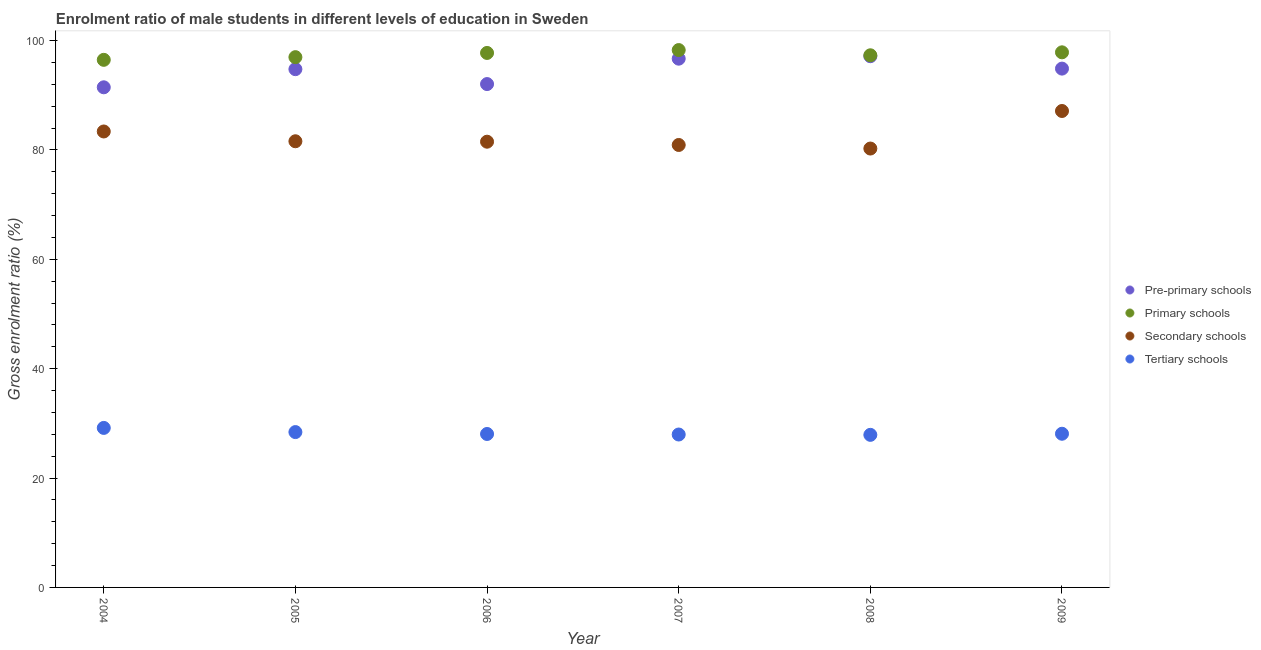How many different coloured dotlines are there?
Offer a very short reply. 4. Is the number of dotlines equal to the number of legend labels?
Offer a terse response. Yes. What is the gross enrolment ratio(female) in primary schools in 2007?
Ensure brevity in your answer.  98.28. Across all years, what is the maximum gross enrolment ratio(female) in secondary schools?
Ensure brevity in your answer.  87.13. Across all years, what is the minimum gross enrolment ratio(female) in secondary schools?
Your answer should be very brief. 80.27. In which year was the gross enrolment ratio(female) in tertiary schools maximum?
Provide a short and direct response. 2004. In which year was the gross enrolment ratio(female) in pre-primary schools minimum?
Provide a succinct answer. 2004. What is the total gross enrolment ratio(female) in pre-primary schools in the graph?
Provide a succinct answer. 567.05. What is the difference between the gross enrolment ratio(female) in primary schools in 2007 and that in 2009?
Ensure brevity in your answer.  0.41. What is the difference between the gross enrolment ratio(female) in primary schools in 2004 and the gross enrolment ratio(female) in tertiary schools in 2005?
Your response must be concise. 68.08. What is the average gross enrolment ratio(female) in pre-primary schools per year?
Your answer should be very brief. 94.51. In the year 2004, what is the difference between the gross enrolment ratio(female) in tertiary schools and gross enrolment ratio(female) in secondary schools?
Give a very brief answer. -54.21. What is the ratio of the gross enrolment ratio(female) in pre-primary schools in 2004 to that in 2005?
Make the answer very short. 0.97. Is the difference between the gross enrolment ratio(female) in secondary schools in 2004 and 2008 greater than the difference between the gross enrolment ratio(female) in primary schools in 2004 and 2008?
Provide a short and direct response. Yes. What is the difference between the highest and the second highest gross enrolment ratio(female) in secondary schools?
Offer a terse response. 3.75. What is the difference between the highest and the lowest gross enrolment ratio(female) in tertiary schools?
Your response must be concise. 1.27. In how many years, is the gross enrolment ratio(female) in secondary schools greater than the average gross enrolment ratio(female) in secondary schools taken over all years?
Your answer should be compact. 2. Is the sum of the gross enrolment ratio(female) in primary schools in 2006 and 2009 greater than the maximum gross enrolment ratio(female) in pre-primary schools across all years?
Offer a very short reply. Yes. Is it the case that in every year, the sum of the gross enrolment ratio(female) in pre-primary schools and gross enrolment ratio(female) in primary schools is greater than the gross enrolment ratio(female) in secondary schools?
Offer a terse response. Yes. Is the gross enrolment ratio(female) in tertiary schools strictly greater than the gross enrolment ratio(female) in pre-primary schools over the years?
Offer a terse response. No. Is the gross enrolment ratio(female) in secondary schools strictly less than the gross enrolment ratio(female) in tertiary schools over the years?
Ensure brevity in your answer.  No. How many dotlines are there?
Ensure brevity in your answer.  4. What is the difference between two consecutive major ticks on the Y-axis?
Provide a short and direct response. 20. Are the values on the major ticks of Y-axis written in scientific E-notation?
Ensure brevity in your answer.  No. Does the graph contain any zero values?
Offer a very short reply. No. Does the graph contain grids?
Make the answer very short. No. How many legend labels are there?
Give a very brief answer. 4. How are the legend labels stacked?
Provide a succinct answer. Vertical. What is the title of the graph?
Ensure brevity in your answer.  Enrolment ratio of male students in different levels of education in Sweden. What is the Gross enrolment ratio (%) in Pre-primary schools in 2004?
Offer a terse response. 91.47. What is the Gross enrolment ratio (%) in Primary schools in 2004?
Offer a terse response. 96.49. What is the Gross enrolment ratio (%) of Secondary schools in 2004?
Offer a very short reply. 83.39. What is the Gross enrolment ratio (%) in Tertiary schools in 2004?
Your answer should be compact. 29.17. What is the Gross enrolment ratio (%) of Pre-primary schools in 2005?
Keep it short and to the point. 94.78. What is the Gross enrolment ratio (%) of Primary schools in 2005?
Give a very brief answer. 96.98. What is the Gross enrolment ratio (%) in Secondary schools in 2005?
Your answer should be compact. 81.6. What is the Gross enrolment ratio (%) in Tertiary schools in 2005?
Offer a terse response. 28.41. What is the Gross enrolment ratio (%) of Pre-primary schools in 2006?
Provide a succinct answer. 92.06. What is the Gross enrolment ratio (%) in Primary schools in 2006?
Ensure brevity in your answer.  97.75. What is the Gross enrolment ratio (%) in Secondary schools in 2006?
Keep it short and to the point. 81.52. What is the Gross enrolment ratio (%) in Tertiary schools in 2006?
Ensure brevity in your answer.  28.06. What is the Gross enrolment ratio (%) in Pre-primary schools in 2007?
Your answer should be very brief. 96.7. What is the Gross enrolment ratio (%) of Primary schools in 2007?
Give a very brief answer. 98.28. What is the Gross enrolment ratio (%) in Secondary schools in 2007?
Make the answer very short. 80.92. What is the Gross enrolment ratio (%) of Tertiary schools in 2007?
Offer a very short reply. 27.97. What is the Gross enrolment ratio (%) of Pre-primary schools in 2008?
Your answer should be compact. 97.15. What is the Gross enrolment ratio (%) in Primary schools in 2008?
Your answer should be compact. 97.32. What is the Gross enrolment ratio (%) in Secondary schools in 2008?
Provide a short and direct response. 80.27. What is the Gross enrolment ratio (%) in Tertiary schools in 2008?
Provide a succinct answer. 27.9. What is the Gross enrolment ratio (%) of Pre-primary schools in 2009?
Give a very brief answer. 94.89. What is the Gross enrolment ratio (%) of Primary schools in 2009?
Keep it short and to the point. 97.86. What is the Gross enrolment ratio (%) of Secondary schools in 2009?
Keep it short and to the point. 87.13. What is the Gross enrolment ratio (%) of Tertiary schools in 2009?
Your response must be concise. 28.11. Across all years, what is the maximum Gross enrolment ratio (%) in Pre-primary schools?
Your response must be concise. 97.15. Across all years, what is the maximum Gross enrolment ratio (%) in Primary schools?
Your response must be concise. 98.28. Across all years, what is the maximum Gross enrolment ratio (%) in Secondary schools?
Ensure brevity in your answer.  87.13. Across all years, what is the maximum Gross enrolment ratio (%) of Tertiary schools?
Make the answer very short. 29.17. Across all years, what is the minimum Gross enrolment ratio (%) of Pre-primary schools?
Provide a succinct answer. 91.47. Across all years, what is the minimum Gross enrolment ratio (%) in Primary schools?
Offer a very short reply. 96.49. Across all years, what is the minimum Gross enrolment ratio (%) of Secondary schools?
Make the answer very short. 80.27. Across all years, what is the minimum Gross enrolment ratio (%) of Tertiary schools?
Provide a succinct answer. 27.9. What is the total Gross enrolment ratio (%) in Pre-primary schools in the graph?
Provide a short and direct response. 567.05. What is the total Gross enrolment ratio (%) of Primary schools in the graph?
Ensure brevity in your answer.  584.68. What is the total Gross enrolment ratio (%) in Secondary schools in the graph?
Keep it short and to the point. 494.82. What is the total Gross enrolment ratio (%) of Tertiary schools in the graph?
Provide a succinct answer. 169.62. What is the difference between the Gross enrolment ratio (%) in Pre-primary schools in 2004 and that in 2005?
Your response must be concise. -3.32. What is the difference between the Gross enrolment ratio (%) in Primary schools in 2004 and that in 2005?
Offer a very short reply. -0.49. What is the difference between the Gross enrolment ratio (%) of Secondary schools in 2004 and that in 2005?
Provide a succinct answer. 1.79. What is the difference between the Gross enrolment ratio (%) in Tertiary schools in 2004 and that in 2005?
Offer a very short reply. 0.76. What is the difference between the Gross enrolment ratio (%) in Pre-primary schools in 2004 and that in 2006?
Provide a succinct answer. -0.59. What is the difference between the Gross enrolment ratio (%) of Primary schools in 2004 and that in 2006?
Your answer should be very brief. -1.26. What is the difference between the Gross enrolment ratio (%) of Secondary schools in 2004 and that in 2006?
Offer a terse response. 1.87. What is the difference between the Gross enrolment ratio (%) in Tertiary schools in 2004 and that in 2006?
Provide a succinct answer. 1.11. What is the difference between the Gross enrolment ratio (%) of Pre-primary schools in 2004 and that in 2007?
Your answer should be very brief. -5.23. What is the difference between the Gross enrolment ratio (%) in Primary schools in 2004 and that in 2007?
Make the answer very short. -1.79. What is the difference between the Gross enrolment ratio (%) in Secondary schools in 2004 and that in 2007?
Ensure brevity in your answer.  2.47. What is the difference between the Gross enrolment ratio (%) in Tertiary schools in 2004 and that in 2007?
Offer a very short reply. 1.21. What is the difference between the Gross enrolment ratio (%) of Pre-primary schools in 2004 and that in 2008?
Your answer should be compact. -5.69. What is the difference between the Gross enrolment ratio (%) in Primary schools in 2004 and that in 2008?
Give a very brief answer. -0.83. What is the difference between the Gross enrolment ratio (%) in Secondary schools in 2004 and that in 2008?
Your response must be concise. 3.12. What is the difference between the Gross enrolment ratio (%) in Tertiary schools in 2004 and that in 2008?
Give a very brief answer. 1.27. What is the difference between the Gross enrolment ratio (%) of Pre-primary schools in 2004 and that in 2009?
Give a very brief answer. -3.42. What is the difference between the Gross enrolment ratio (%) of Primary schools in 2004 and that in 2009?
Your answer should be very brief. -1.37. What is the difference between the Gross enrolment ratio (%) of Secondary schools in 2004 and that in 2009?
Provide a short and direct response. -3.75. What is the difference between the Gross enrolment ratio (%) in Tertiary schools in 2004 and that in 2009?
Provide a short and direct response. 1.07. What is the difference between the Gross enrolment ratio (%) in Pre-primary schools in 2005 and that in 2006?
Make the answer very short. 2.72. What is the difference between the Gross enrolment ratio (%) of Primary schools in 2005 and that in 2006?
Keep it short and to the point. -0.77. What is the difference between the Gross enrolment ratio (%) in Secondary schools in 2005 and that in 2006?
Your response must be concise. 0.08. What is the difference between the Gross enrolment ratio (%) in Tertiary schools in 2005 and that in 2006?
Your response must be concise. 0.35. What is the difference between the Gross enrolment ratio (%) of Pre-primary schools in 2005 and that in 2007?
Ensure brevity in your answer.  -1.92. What is the difference between the Gross enrolment ratio (%) of Primary schools in 2005 and that in 2007?
Provide a short and direct response. -1.3. What is the difference between the Gross enrolment ratio (%) in Secondary schools in 2005 and that in 2007?
Give a very brief answer. 0.68. What is the difference between the Gross enrolment ratio (%) of Tertiary schools in 2005 and that in 2007?
Ensure brevity in your answer.  0.44. What is the difference between the Gross enrolment ratio (%) in Pre-primary schools in 2005 and that in 2008?
Give a very brief answer. -2.37. What is the difference between the Gross enrolment ratio (%) of Primary schools in 2005 and that in 2008?
Give a very brief answer. -0.34. What is the difference between the Gross enrolment ratio (%) of Secondary schools in 2005 and that in 2008?
Offer a terse response. 1.33. What is the difference between the Gross enrolment ratio (%) of Tertiary schools in 2005 and that in 2008?
Your answer should be very brief. 0.51. What is the difference between the Gross enrolment ratio (%) of Pre-primary schools in 2005 and that in 2009?
Give a very brief answer. -0.1. What is the difference between the Gross enrolment ratio (%) in Primary schools in 2005 and that in 2009?
Make the answer very short. -0.88. What is the difference between the Gross enrolment ratio (%) of Secondary schools in 2005 and that in 2009?
Provide a succinct answer. -5.54. What is the difference between the Gross enrolment ratio (%) in Tertiary schools in 2005 and that in 2009?
Your answer should be very brief. 0.31. What is the difference between the Gross enrolment ratio (%) in Pre-primary schools in 2006 and that in 2007?
Your response must be concise. -4.64. What is the difference between the Gross enrolment ratio (%) of Primary schools in 2006 and that in 2007?
Keep it short and to the point. -0.53. What is the difference between the Gross enrolment ratio (%) of Secondary schools in 2006 and that in 2007?
Your answer should be very brief. 0.6. What is the difference between the Gross enrolment ratio (%) in Tertiary schools in 2006 and that in 2007?
Your response must be concise. 0.1. What is the difference between the Gross enrolment ratio (%) in Pre-primary schools in 2006 and that in 2008?
Provide a succinct answer. -5.09. What is the difference between the Gross enrolment ratio (%) of Primary schools in 2006 and that in 2008?
Your answer should be compact. 0.43. What is the difference between the Gross enrolment ratio (%) in Secondary schools in 2006 and that in 2008?
Your answer should be very brief. 1.25. What is the difference between the Gross enrolment ratio (%) in Tertiary schools in 2006 and that in 2008?
Keep it short and to the point. 0.16. What is the difference between the Gross enrolment ratio (%) of Pre-primary schools in 2006 and that in 2009?
Your response must be concise. -2.83. What is the difference between the Gross enrolment ratio (%) of Primary schools in 2006 and that in 2009?
Provide a succinct answer. -0.11. What is the difference between the Gross enrolment ratio (%) of Secondary schools in 2006 and that in 2009?
Keep it short and to the point. -5.62. What is the difference between the Gross enrolment ratio (%) of Tertiary schools in 2006 and that in 2009?
Keep it short and to the point. -0.04. What is the difference between the Gross enrolment ratio (%) of Pre-primary schools in 2007 and that in 2008?
Provide a short and direct response. -0.45. What is the difference between the Gross enrolment ratio (%) in Primary schools in 2007 and that in 2008?
Give a very brief answer. 0.95. What is the difference between the Gross enrolment ratio (%) in Secondary schools in 2007 and that in 2008?
Your answer should be compact. 0.65. What is the difference between the Gross enrolment ratio (%) in Tertiary schools in 2007 and that in 2008?
Give a very brief answer. 0.06. What is the difference between the Gross enrolment ratio (%) of Pre-primary schools in 2007 and that in 2009?
Keep it short and to the point. 1.82. What is the difference between the Gross enrolment ratio (%) in Primary schools in 2007 and that in 2009?
Your answer should be very brief. 0.41. What is the difference between the Gross enrolment ratio (%) of Secondary schools in 2007 and that in 2009?
Your answer should be compact. -6.21. What is the difference between the Gross enrolment ratio (%) in Tertiary schools in 2007 and that in 2009?
Your answer should be compact. -0.14. What is the difference between the Gross enrolment ratio (%) in Pre-primary schools in 2008 and that in 2009?
Offer a very short reply. 2.27. What is the difference between the Gross enrolment ratio (%) in Primary schools in 2008 and that in 2009?
Give a very brief answer. -0.54. What is the difference between the Gross enrolment ratio (%) in Secondary schools in 2008 and that in 2009?
Your answer should be very brief. -6.87. What is the difference between the Gross enrolment ratio (%) in Tertiary schools in 2008 and that in 2009?
Keep it short and to the point. -0.2. What is the difference between the Gross enrolment ratio (%) of Pre-primary schools in 2004 and the Gross enrolment ratio (%) of Primary schools in 2005?
Ensure brevity in your answer.  -5.51. What is the difference between the Gross enrolment ratio (%) of Pre-primary schools in 2004 and the Gross enrolment ratio (%) of Secondary schools in 2005?
Give a very brief answer. 9.87. What is the difference between the Gross enrolment ratio (%) of Pre-primary schools in 2004 and the Gross enrolment ratio (%) of Tertiary schools in 2005?
Offer a very short reply. 63.06. What is the difference between the Gross enrolment ratio (%) of Primary schools in 2004 and the Gross enrolment ratio (%) of Secondary schools in 2005?
Your answer should be compact. 14.89. What is the difference between the Gross enrolment ratio (%) of Primary schools in 2004 and the Gross enrolment ratio (%) of Tertiary schools in 2005?
Your answer should be compact. 68.08. What is the difference between the Gross enrolment ratio (%) in Secondary schools in 2004 and the Gross enrolment ratio (%) in Tertiary schools in 2005?
Your answer should be compact. 54.98. What is the difference between the Gross enrolment ratio (%) of Pre-primary schools in 2004 and the Gross enrolment ratio (%) of Primary schools in 2006?
Give a very brief answer. -6.28. What is the difference between the Gross enrolment ratio (%) of Pre-primary schools in 2004 and the Gross enrolment ratio (%) of Secondary schools in 2006?
Offer a very short reply. 9.95. What is the difference between the Gross enrolment ratio (%) in Pre-primary schools in 2004 and the Gross enrolment ratio (%) in Tertiary schools in 2006?
Your answer should be very brief. 63.4. What is the difference between the Gross enrolment ratio (%) in Primary schools in 2004 and the Gross enrolment ratio (%) in Secondary schools in 2006?
Provide a short and direct response. 14.97. What is the difference between the Gross enrolment ratio (%) of Primary schools in 2004 and the Gross enrolment ratio (%) of Tertiary schools in 2006?
Your answer should be compact. 68.43. What is the difference between the Gross enrolment ratio (%) of Secondary schools in 2004 and the Gross enrolment ratio (%) of Tertiary schools in 2006?
Provide a short and direct response. 55.32. What is the difference between the Gross enrolment ratio (%) in Pre-primary schools in 2004 and the Gross enrolment ratio (%) in Primary schools in 2007?
Provide a short and direct response. -6.81. What is the difference between the Gross enrolment ratio (%) in Pre-primary schools in 2004 and the Gross enrolment ratio (%) in Secondary schools in 2007?
Provide a short and direct response. 10.55. What is the difference between the Gross enrolment ratio (%) in Pre-primary schools in 2004 and the Gross enrolment ratio (%) in Tertiary schools in 2007?
Your answer should be very brief. 63.5. What is the difference between the Gross enrolment ratio (%) of Primary schools in 2004 and the Gross enrolment ratio (%) of Secondary schools in 2007?
Offer a very short reply. 15.57. What is the difference between the Gross enrolment ratio (%) of Primary schools in 2004 and the Gross enrolment ratio (%) of Tertiary schools in 2007?
Make the answer very short. 68.52. What is the difference between the Gross enrolment ratio (%) in Secondary schools in 2004 and the Gross enrolment ratio (%) in Tertiary schools in 2007?
Make the answer very short. 55.42. What is the difference between the Gross enrolment ratio (%) of Pre-primary schools in 2004 and the Gross enrolment ratio (%) of Primary schools in 2008?
Your response must be concise. -5.86. What is the difference between the Gross enrolment ratio (%) of Pre-primary schools in 2004 and the Gross enrolment ratio (%) of Secondary schools in 2008?
Provide a short and direct response. 11.2. What is the difference between the Gross enrolment ratio (%) in Pre-primary schools in 2004 and the Gross enrolment ratio (%) in Tertiary schools in 2008?
Keep it short and to the point. 63.56. What is the difference between the Gross enrolment ratio (%) of Primary schools in 2004 and the Gross enrolment ratio (%) of Secondary schools in 2008?
Your response must be concise. 16.22. What is the difference between the Gross enrolment ratio (%) of Primary schools in 2004 and the Gross enrolment ratio (%) of Tertiary schools in 2008?
Make the answer very short. 68.59. What is the difference between the Gross enrolment ratio (%) of Secondary schools in 2004 and the Gross enrolment ratio (%) of Tertiary schools in 2008?
Give a very brief answer. 55.48. What is the difference between the Gross enrolment ratio (%) of Pre-primary schools in 2004 and the Gross enrolment ratio (%) of Primary schools in 2009?
Your answer should be compact. -6.4. What is the difference between the Gross enrolment ratio (%) in Pre-primary schools in 2004 and the Gross enrolment ratio (%) in Secondary schools in 2009?
Make the answer very short. 4.33. What is the difference between the Gross enrolment ratio (%) in Pre-primary schools in 2004 and the Gross enrolment ratio (%) in Tertiary schools in 2009?
Offer a terse response. 63.36. What is the difference between the Gross enrolment ratio (%) of Primary schools in 2004 and the Gross enrolment ratio (%) of Secondary schools in 2009?
Your answer should be very brief. 9.36. What is the difference between the Gross enrolment ratio (%) of Primary schools in 2004 and the Gross enrolment ratio (%) of Tertiary schools in 2009?
Provide a succinct answer. 68.39. What is the difference between the Gross enrolment ratio (%) of Secondary schools in 2004 and the Gross enrolment ratio (%) of Tertiary schools in 2009?
Ensure brevity in your answer.  55.28. What is the difference between the Gross enrolment ratio (%) in Pre-primary schools in 2005 and the Gross enrolment ratio (%) in Primary schools in 2006?
Make the answer very short. -2.97. What is the difference between the Gross enrolment ratio (%) of Pre-primary schools in 2005 and the Gross enrolment ratio (%) of Secondary schools in 2006?
Your answer should be compact. 13.27. What is the difference between the Gross enrolment ratio (%) of Pre-primary schools in 2005 and the Gross enrolment ratio (%) of Tertiary schools in 2006?
Your answer should be very brief. 66.72. What is the difference between the Gross enrolment ratio (%) of Primary schools in 2005 and the Gross enrolment ratio (%) of Secondary schools in 2006?
Your answer should be very brief. 15.46. What is the difference between the Gross enrolment ratio (%) in Primary schools in 2005 and the Gross enrolment ratio (%) in Tertiary schools in 2006?
Your answer should be compact. 68.92. What is the difference between the Gross enrolment ratio (%) of Secondary schools in 2005 and the Gross enrolment ratio (%) of Tertiary schools in 2006?
Ensure brevity in your answer.  53.54. What is the difference between the Gross enrolment ratio (%) of Pre-primary schools in 2005 and the Gross enrolment ratio (%) of Primary schools in 2007?
Offer a very short reply. -3.49. What is the difference between the Gross enrolment ratio (%) of Pre-primary schools in 2005 and the Gross enrolment ratio (%) of Secondary schools in 2007?
Provide a short and direct response. 13.86. What is the difference between the Gross enrolment ratio (%) in Pre-primary schools in 2005 and the Gross enrolment ratio (%) in Tertiary schools in 2007?
Your answer should be very brief. 66.82. What is the difference between the Gross enrolment ratio (%) in Primary schools in 2005 and the Gross enrolment ratio (%) in Secondary schools in 2007?
Make the answer very short. 16.06. What is the difference between the Gross enrolment ratio (%) in Primary schools in 2005 and the Gross enrolment ratio (%) in Tertiary schools in 2007?
Your answer should be compact. 69.01. What is the difference between the Gross enrolment ratio (%) in Secondary schools in 2005 and the Gross enrolment ratio (%) in Tertiary schools in 2007?
Your response must be concise. 53.63. What is the difference between the Gross enrolment ratio (%) in Pre-primary schools in 2005 and the Gross enrolment ratio (%) in Primary schools in 2008?
Offer a very short reply. -2.54. What is the difference between the Gross enrolment ratio (%) in Pre-primary schools in 2005 and the Gross enrolment ratio (%) in Secondary schools in 2008?
Your answer should be very brief. 14.52. What is the difference between the Gross enrolment ratio (%) in Pre-primary schools in 2005 and the Gross enrolment ratio (%) in Tertiary schools in 2008?
Offer a very short reply. 66.88. What is the difference between the Gross enrolment ratio (%) in Primary schools in 2005 and the Gross enrolment ratio (%) in Secondary schools in 2008?
Your response must be concise. 16.71. What is the difference between the Gross enrolment ratio (%) of Primary schools in 2005 and the Gross enrolment ratio (%) of Tertiary schools in 2008?
Your answer should be compact. 69.07. What is the difference between the Gross enrolment ratio (%) in Secondary schools in 2005 and the Gross enrolment ratio (%) in Tertiary schools in 2008?
Your answer should be very brief. 53.69. What is the difference between the Gross enrolment ratio (%) of Pre-primary schools in 2005 and the Gross enrolment ratio (%) of Primary schools in 2009?
Make the answer very short. -3.08. What is the difference between the Gross enrolment ratio (%) in Pre-primary schools in 2005 and the Gross enrolment ratio (%) in Secondary schools in 2009?
Your response must be concise. 7.65. What is the difference between the Gross enrolment ratio (%) of Pre-primary schools in 2005 and the Gross enrolment ratio (%) of Tertiary schools in 2009?
Provide a short and direct response. 66.68. What is the difference between the Gross enrolment ratio (%) in Primary schools in 2005 and the Gross enrolment ratio (%) in Secondary schools in 2009?
Ensure brevity in your answer.  9.85. What is the difference between the Gross enrolment ratio (%) of Primary schools in 2005 and the Gross enrolment ratio (%) of Tertiary schools in 2009?
Keep it short and to the point. 68.87. What is the difference between the Gross enrolment ratio (%) of Secondary schools in 2005 and the Gross enrolment ratio (%) of Tertiary schools in 2009?
Offer a very short reply. 53.49. What is the difference between the Gross enrolment ratio (%) in Pre-primary schools in 2006 and the Gross enrolment ratio (%) in Primary schools in 2007?
Your answer should be compact. -6.22. What is the difference between the Gross enrolment ratio (%) in Pre-primary schools in 2006 and the Gross enrolment ratio (%) in Secondary schools in 2007?
Provide a short and direct response. 11.14. What is the difference between the Gross enrolment ratio (%) of Pre-primary schools in 2006 and the Gross enrolment ratio (%) of Tertiary schools in 2007?
Offer a very short reply. 64.09. What is the difference between the Gross enrolment ratio (%) in Primary schools in 2006 and the Gross enrolment ratio (%) in Secondary schools in 2007?
Offer a terse response. 16.83. What is the difference between the Gross enrolment ratio (%) in Primary schools in 2006 and the Gross enrolment ratio (%) in Tertiary schools in 2007?
Keep it short and to the point. 69.78. What is the difference between the Gross enrolment ratio (%) of Secondary schools in 2006 and the Gross enrolment ratio (%) of Tertiary schools in 2007?
Offer a very short reply. 53.55. What is the difference between the Gross enrolment ratio (%) of Pre-primary schools in 2006 and the Gross enrolment ratio (%) of Primary schools in 2008?
Give a very brief answer. -5.26. What is the difference between the Gross enrolment ratio (%) of Pre-primary schools in 2006 and the Gross enrolment ratio (%) of Secondary schools in 2008?
Make the answer very short. 11.79. What is the difference between the Gross enrolment ratio (%) of Pre-primary schools in 2006 and the Gross enrolment ratio (%) of Tertiary schools in 2008?
Your response must be concise. 64.15. What is the difference between the Gross enrolment ratio (%) of Primary schools in 2006 and the Gross enrolment ratio (%) of Secondary schools in 2008?
Provide a succinct answer. 17.48. What is the difference between the Gross enrolment ratio (%) of Primary schools in 2006 and the Gross enrolment ratio (%) of Tertiary schools in 2008?
Your answer should be compact. 69.85. What is the difference between the Gross enrolment ratio (%) of Secondary schools in 2006 and the Gross enrolment ratio (%) of Tertiary schools in 2008?
Offer a terse response. 53.61. What is the difference between the Gross enrolment ratio (%) of Pre-primary schools in 2006 and the Gross enrolment ratio (%) of Primary schools in 2009?
Ensure brevity in your answer.  -5.81. What is the difference between the Gross enrolment ratio (%) of Pre-primary schools in 2006 and the Gross enrolment ratio (%) of Secondary schools in 2009?
Your answer should be compact. 4.93. What is the difference between the Gross enrolment ratio (%) in Pre-primary schools in 2006 and the Gross enrolment ratio (%) in Tertiary schools in 2009?
Your response must be concise. 63.95. What is the difference between the Gross enrolment ratio (%) in Primary schools in 2006 and the Gross enrolment ratio (%) in Secondary schools in 2009?
Provide a short and direct response. 10.62. What is the difference between the Gross enrolment ratio (%) of Primary schools in 2006 and the Gross enrolment ratio (%) of Tertiary schools in 2009?
Your answer should be compact. 69.65. What is the difference between the Gross enrolment ratio (%) in Secondary schools in 2006 and the Gross enrolment ratio (%) in Tertiary schools in 2009?
Your answer should be compact. 53.41. What is the difference between the Gross enrolment ratio (%) of Pre-primary schools in 2007 and the Gross enrolment ratio (%) of Primary schools in 2008?
Make the answer very short. -0.62. What is the difference between the Gross enrolment ratio (%) of Pre-primary schools in 2007 and the Gross enrolment ratio (%) of Secondary schools in 2008?
Offer a terse response. 16.43. What is the difference between the Gross enrolment ratio (%) of Pre-primary schools in 2007 and the Gross enrolment ratio (%) of Tertiary schools in 2008?
Provide a short and direct response. 68.8. What is the difference between the Gross enrolment ratio (%) of Primary schools in 2007 and the Gross enrolment ratio (%) of Secondary schools in 2008?
Offer a very short reply. 18.01. What is the difference between the Gross enrolment ratio (%) in Primary schools in 2007 and the Gross enrolment ratio (%) in Tertiary schools in 2008?
Your answer should be compact. 70.37. What is the difference between the Gross enrolment ratio (%) in Secondary schools in 2007 and the Gross enrolment ratio (%) in Tertiary schools in 2008?
Offer a very short reply. 53.01. What is the difference between the Gross enrolment ratio (%) in Pre-primary schools in 2007 and the Gross enrolment ratio (%) in Primary schools in 2009?
Your response must be concise. -1.16. What is the difference between the Gross enrolment ratio (%) in Pre-primary schools in 2007 and the Gross enrolment ratio (%) in Secondary schools in 2009?
Provide a succinct answer. 9.57. What is the difference between the Gross enrolment ratio (%) of Pre-primary schools in 2007 and the Gross enrolment ratio (%) of Tertiary schools in 2009?
Offer a very short reply. 68.6. What is the difference between the Gross enrolment ratio (%) in Primary schools in 2007 and the Gross enrolment ratio (%) in Secondary schools in 2009?
Provide a succinct answer. 11.14. What is the difference between the Gross enrolment ratio (%) in Primary schools in 2007 and the Gross enrolment ratio (%) in Tertiary schools in 2009?
Provide a short and direct response. 70.17. What is the difference between the Gross enrolment ratio (%) in Secondary schools in 2007 and the Gross enrolment ratio (%) in Tertiary schools in 2009?
Offer a terse response. 52.81. What is the difference between the Gross enrolment ratio (%) of Pre-primary schools in 2008 and the Gross enrolment ratio (%) of Primary schools in 2009?
Provide a succinct answer. -0.71. What is the difference between the Gross enrolment ratio (%) in Pre-primary schools in 2008 and the Gross enrolment ratio (%) in Secondary schools in 2009?
Your response must be concise. 10.02. What is the difference between the Gross enrolment ratio (%) of Pre-primary schools in 2008 and the Gross enrolment ratio (%) of Tertiary schools in 2009?
Your answer should be compact. 69.05. What is the difference between the Gross enrolment ratio (%) of Primary schools in 2008 and the Gross enrolment ratio (%) of Secondary schools in 2009?
Your response must be concise. 10.19. What is the difference between the Gross enrolment ratio (%) of Primary schools in 2008 and the Gross enrolment ratio (%) of Tertiary schools in 2009?
Offer a very short reply. 69.22. What is the difference between the Gross enrolment ratio (%) in Secondary schools in 2008 and the Gross enrolment ratio (%) in Tertiary schools in 2009?
Keep it short and to the point. 52.16. What is the average Gross enrolment ratio (%) in Pre-primary schools per year?
Make the answer very short. 94.51. What is the average Gross enrolment ratio (%) of Primary schools per year?
Your answer should be very brief. 97.45. What is the average Gross enrolment ratio (%) in Secondary schools per year?
Your answer should be very brief. 82.47. What is the average Gross enrolment ratio (%) of Tertiary schools per year?
Provide a succinct answer. 28.27. In the year 2004, what is the difference between the Gross enrolment ratio (%) of Pre-primary schools and Gross enrolment ratio (%) of Primary schools?
Provide a short and direct response. -5.02. In the year 2004, what is the difference between the Gross enrolment ratio (%) in Pre-primary schools and Gross enrolment ratio (%) in Secondary schools?
Your answer should be very brief. 8.08. In the year 2004, what is the difference between the Gross enrolment ratio (%) of Pre-primary schools and Gross enrolment ratio (%) of Tertiary schools?
Offer a very short reply. 62.29. In the year 2004, what is the difference between the Gross enrolment ratio (%) in Primary schools and Gross enrolment ratio (%) in Secondary schools?
Your answer should be compact. 13.1. In the year 2004, what is the difference between the Gross enrolment ratio (%) of Primary schools and Gross enrolment ratio (%) of Tertiary schools?
Make the answer very short. 67.32. In the year 2004, what is the difference between the Gross enrolment ratio (%) of Secondary schools and Gross enrolment ratio (%) of Tertiary schools?
Your answer should be compact. 54.22. In the year 2005, what is the difference between the Gross enrolment ratio (%) of Pre-primary schools and Gross enrolment ratio (%) of Primary schools?
Your answer should be compact. -2.2. In the year 2005, what is the difference between the Gross enrolment ratio (%) in Pre-primary schools and Gross enrolment ratio (%) in Secondary schools?
Keep it short and to the point. 13.18. In the year 2005, what is the difference between the Gross enrolment ratio (%) of Pre-primary schools and Gross enrolment ratio (%) of Tertiary schools?
Give a very brief answer. 66.37. In the year 2005, what is the difference between the Gross enrolment ratio (%) in Primary schools and Gross enrolment ratio (%) in Secondary schools?
Offer a very short reply. 15.38. In the year 2005, what is the difference between the Gross enrolment ratio (%) in Primary schools and Gross enrolment ratio (%) in Tertiary schools?
Your answer should be very brief. 68.57. In the year 2005, what is the difference between the Gross enrolment ratio (%) of Secondary schools and Gross enrolment ratio (%) of Tertiary schools?
Make the answer very short. 53.19. In the year 2006, what is the difference between the Gross enrolment ratio (%) of Pre-primary schools and Gross enrolment ratio (%) of Primary schools?
Give a very brief answer. -5.69. In the year 2006, what is the difference between the Gross enrolment ratio (%) in Pre-primary schools and Gross enrolment ratio (%) in Secondary schools?
Your answer should be very brief. 10.54. In the year 2006, what is the difference between the Gross enrolment ratio (%) of Pre-primary schools and Gross enrolment ratio (%) of Tertiary schools?
Give a very brief answer. 64. In the year 2006, what is the difference between the Gross enrolment ratio (%) of Primary schools and Gross enrolment ratio (%) of Secondary schools?
Give a very brief answer. 16.23. In the year 2006, what is the difference between the Gross enrolment ratio (%) of Primary schools and Gross enrolment ratio (%) of Tertiary schools?
Your response must be concise. 69.69. In the year 2006, what is the difference between the Gross enrolment ratio (%) of Secondary schools and Gross enrolment ratio (%) of Tertiary schools?
Offer a very short reply. 53.45. In the year 2007, what is the difference between the Gross enrolment ratio (%) in Pre-primary schools and Gross enrolment ratio (%) in Primary schools?
Offer a very short reply. -1.58. In the year 2007, what is the difference between the Gross enrolment ratio (%) of Pre-primary schools and Gross enrolment ratio (%) of Secondary schools?
Ensure brevity in your answer.  15.78. In the year 2007, what is the difference between the Gross enrolment ratio (%) of Pre-primary schools and Gross enrolment ratio (%) of Tertiary schools?
Your response must be concise. 68.73. In the year 2007, what is the difference between the Gross enrolment ratio (%) of Primary schools and Gross enrolment ratio (%) of Secondary schools?
Keep it short and to the point. 17.36. In the year 2007, what is the difference between the Gross enrolment ratio (%) of Primary schools and Gross enrolment ratio (%) of Tertiary schools?
Your response must be concise. 70.31. In the year 2007, what is the difference between the Gross enrolment ratio (%) of Secondary schools and Gross enrolment ratio (%) of Tertiary schools?
Ensure brevity in your answer.  52.95. In the year 2008, what is the difference between the Gross enrolment ratio (%) in Pre-primary schools and Gross enrolment ratio (%) in Primary schools?
Your answer should be compact. -0.17. In the year 2008, what is the difference between the Gross enrolment ratio (%) of Pre-primary schools and Gross enrolment ratio (%) of Secondary schools?
Provide a short and direct response. 16.89. In the year 2008, what is the difference between the Gross enrolment ratio (%) of Pre-primary schools and Gross enrolment ratio (%) of Tertiary schools?
Your response must be concise. 69.25. In the year 2008, what is the difference between the Gross enrolment ratio (%) of Primary schools and Gross enrolment ratio (%) of Secondary schools?
Ensure brevity in your answer.  17.06. In the year 2008, what is the difference between the Gross enrolment ratio (%) of Primary schools and Gross enrolment ratio (%) of Tertiary schools?
Provide a short and direct response. 69.42. In the year 2008, what is the difference between the Gross enrolment ratio (%) in Secondary schools and Gross enrolment ratio (%) in Tertiary schools?
Offer a very short reply. 52.36. In the year 2009, what is the difference between the Gross enrolment ratio (%) of Pre-primary schools and Gross enrolment ratio (%) of Primary schools?
Make the answer very short. -2.98. In the year 2009, what is the difference between the Gross enrolment ratio (%) of Pre-primary schools and Gross enrolment ratio (%) of Secondary schools?
Keep it short and to the point. 7.75. In the year 2009, what is the difference between the Gross enrolment ratio (%) in Pre-primary schools and Gross enrolment ratio (%) in Tertiary schools?
Offer a very short reply. 66.78. In the year 2009, what is the difference between the Gross enrolment ratio (%) of Primary schools and Gross enrolment ratio (%) of Secondary schools?
Your answer should be very brief. 10.73. In the year 2009, what is the difference between the Gross enrolment ratio (%) in Primary schools and Gross enrolment ratio (%) in Tertiary schools?
Give a very brief answer. 69.76. In the year 2009, what is the difference between the Gross enrolment ratio (%) in Secondary schools and Gross enrolment ratio (%) in Tertiary schools?
Provide a succinct answer. 59.03. What is the ratio of the Gross enrolment ratio (%) in Primary schools in 2004 to that in 2005?
Ensure brevity in your answer.  0.99. What is the ratio of the Gross enrolment ratio (%) of Secondary schools in 2004 to that in 2005?
Offer a terse response. 1.02. What is the ratio of the Gross enrolment ratio (%) of Tertiary schools in 2004 to that in 2005?
Provide a succinct answer. 1.03. What is the ratio of the Gross enrolment ratio (%) in Pre-primary schools in 2004 to that in 2006?
Your response must be concise. 0.99. What is the ratio of the Gross enrolment ratio (%) of Primary schools in 2004 to that in 2006?
Ensure brevity in your answer.  0.99. What is the ratio of the Gross enrolment ratio (%) in Secondary schools in 2004 to that in 2006?
Offer a very short reply. 1.02. What is the ratio of the Gross enrolment ratio (%) of Tertiary schools in 2004 to that in 2006?
Offer a very short reply. 1.04. What is the ratio of the Gross enrolment ratio (%) in Pre-primary schools in 2004 to that in 2007?
Ensure brevity in your answer.  0.95. What is the ratio of the Gross enrolment ratio (%) of Primary schools in 2004 to that in 2007?
Make the answer very short. 0.98. What is the ratio of the Gross enrolment ratio (%) of Secondary schools in 2004 to that in 2007?
Your response must be concise. 1.03. What is the ratio of the Gross enrolment ratio (%) of Tertiary schools in 2004 to that in 2007?
Make the answer very short. 1.04. What is the ratio of the Gross enrolment ratio (%) in Pre-primary schools in 2004 to that in 2008?
Provide a succinct answer. 0.94. What is the ratio of the Gross enrolment ratio (%) in Primary schools in 2004 to that in 2008?
Ensure brevity in your answer.  0.99. What is the ratio of the Gross enrolment ratio (%) of Secondary schools in 2004 to that in 2008?
Your answer should be compact. 1.04. What is the ratio of the Gross enrolment ratio (%) in Tertiary schools in 2004 to that in 2008?
Offer a terse response. 1.05. What is the ratio of the Gross enrolment ratio (%) of Primary schools in 2004 to that in 2009?
Keep it short and to the point. 0.99. What is the ratio of the Gross enrolment ratio (%) in Secondary schools in 2004 to that in 2009?
Make the answer very short. 0.96. What is the ratio of the Gross enrolment ratio (%) in Tertiary schools in 2004 to that in 2009?
Make the answer very short. 1.04. What is the ratio of the Gross enrolment ratio (%) of Pre-primary schools in 2005 to that in 2006?
Offer a terse response. 1.03. What is the ratio of the Gross enrolment ratio (%) in Secondary schools in 2005 to that in 2006?
Offer a very short reply. 1. What is the ratio of the Gross enrolment ratio (%) in Tertiary schools in 2005 to that in 2006?
Offer a terse response. 1.01. What is the ratio of the Gross enrolment ratio (%) of Pre-primary schools in 2005 to that in 2007?
Your answer should be very brief. 0.98. What is the ratio of the Gross enrolment ratio (%) in Secondary schools in 2005 to that in 2007?
Keep it short and to the point. 1.01. What is the ratio of the Gross enrolment ratio (%) in Tertiary schools in 2005 to that in 2007?
Offer a terse response. 1.02. What is the ratio of the Gross enrolment ratio (%) in Pre-primary schools in 2005 to that in 2008?
Your response must be concise. 0.98. What is the ratio of the Gross enrolment ratio (%) of Secondary schools in 2005 to that in 2008?
Ensure brevity in your answer.  1.02. What is the ratio of the Gross enrolment ratio (%) of Tertiary schools in 2005 to that in 2008?
Keep it short and to the point. 1.02. What is the ratio of the Gross enrolment ratio (%) in Pre-primary schools in 2005 to that in 2009?
Your answer should be very brief. 1. What is the ratio of the Gross enrolment ratio (%) of Primary schools in 2005 to that in 2009?
Ensure brevity in your answer.  0.99. What is the ratio of the Gross enrolment ratio (%) of Secondary schools in 2005 to that in 2009?
Give a very brief answer. 0.94. What is the ratio of the Gross enrolment ratio (%) in Tertiary schools in 2005 to that in 2009?
Make the answer very short. 1.01. What is the ratio of the Gross enrolment ratio (%) in Pre-primary schools in 2006 to that in 2007?
Offer a very short reply. 0.95. What is the ratio of the Gross enrolment ratio (%) of Secondary schools in 2006 to that in 2007?
Ensure brevity in your answer.  1.01. What is the ratio of the Gross enrolment ratio (%) in Pre-primary schools in 2006 to that in 2008?
Ensure brevity in your answer.  0.95. What is the ratio of the Gross enrolment ratio (%) in Primary schools in 2006 to that in 2008?
Your answer should be very brief. 1. What is the ratio of the Gross enrolment ratio (%) of Secondary schools in 2006 to that in 2008?
Provide a succinct answer. 1.02. What is the ratio of the Gross enrolment ratio (%) in Pre-primary schools in 2006 to that in 2009?
Make the answer very short. 0.97. What is the ratio of the Gross enrolment ratio (%) of Primary schools in 2006 to that in 2009?
Offer a terse response. 1. What is the ratio of the Gross enrolment ratio (%) of Secondary schools in 2006 to that in 2009?
Ensure brevity in your answer.  0.94. What is the ratio of the Gross enrolment ratio (%) of Tertiary schools in 2006 to that in 2009?
Your answer should be very brief. 1. What is the ratio of the Gross enrolment ratio (%) of Pre-primary schools in 2007 to that in 2008?
Offer a terse response. 1. What is the ratio of the Gross enrolment ratio (%) of Primary schools in 2007 to that in 2008?
Your answer should be very brief. 1.01. What is the ratio of the Gross enrolment ratio (%) in Secondary schools in 2007 to that in 2008?
Offer a terse response. 1.01. What is the ratio of the Gross enrolment ratio (%) of Tertiary schools in 2007 to that in 2008?
Your answer should be compact. 1. What is the ratio of the Gross enrolment ratio (%) in Pre-primary schools in 2007 to that in 2009?
Provide a short and direct response. 1.02. What is the ratio of the Gross enrolment ratio (%) in Primary schools in 2007 to that in 2009?
Your answer should be compact. 1. What is the ratio of the Gross enrolment ratio (%) of Secondary schools in 2007 to that in 2009?
Provide a succinct answer. 0.93. What is the ratio of the Gross enrolment ratio (%) in Pre-primary schools in 2008 to that in 2009?
Ensure brevity in your answer.  1.02. What is the ratio of the Gross enrolment ratio (%) of Secondary schools in 2008 to that in 2009?
Offer a very short reply. 0.92. What is the ratio of the Gross enrolment ratio (%) of Tertiary schools in 2008 to that in 2009?
Keep it short and to the point. 0.99. What is the difference between the highest and the second highest Gross enrolment ratio (%) in Pre-primary schools?
Offer a terse response. 0.45. What is the difference between the highest and the second highest Gross enrolment ratio (%) of Primary schools?
Your answer should be very brief. 0.41. What is the difference between the highest and the second highest Gross enrolment ratio (%) of Secondary schools?
Provide a succinct answer. 3.75. What is the difference between the highest and the second highest Gross enrolment ratio (%) of Tertiary schools?
Offer a very short reply. 0.76. What is the difference between the highest and the lowest Gross enrolment ratio (%) of Pre-primary schools?
Offer a terse response. 5.69. What is the difference between the highest and the lowest Gross enrolment ratio (%) of Primary schools?
Your answer should be compact. 1.79. What is the difference between the highest and the lowest Gross enrolment ratio (%) in Secondary schools?
Offer a very short reply. 6.87. What is the difference between the highest and the lowest Gross enrolment ratio (%) of Tertiary schools?
Keep it short and to the point. 1.27. 